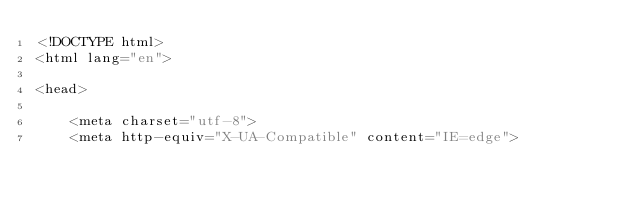<code> <loc_0><loc_0><loc_500><loc_500><_PHP_><!DOCTYPE html>
<html lang="en">

<head>

    <meta charset="utf-8">
    <meta http-equiv="X-UA-Compatible" content="IE=edge"></code> 